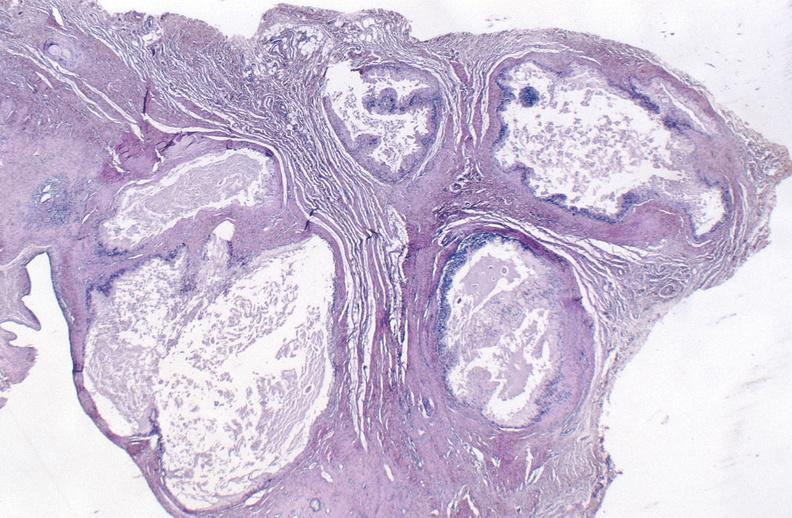what is present?
Answer the question using a single word or phrase. Joints 